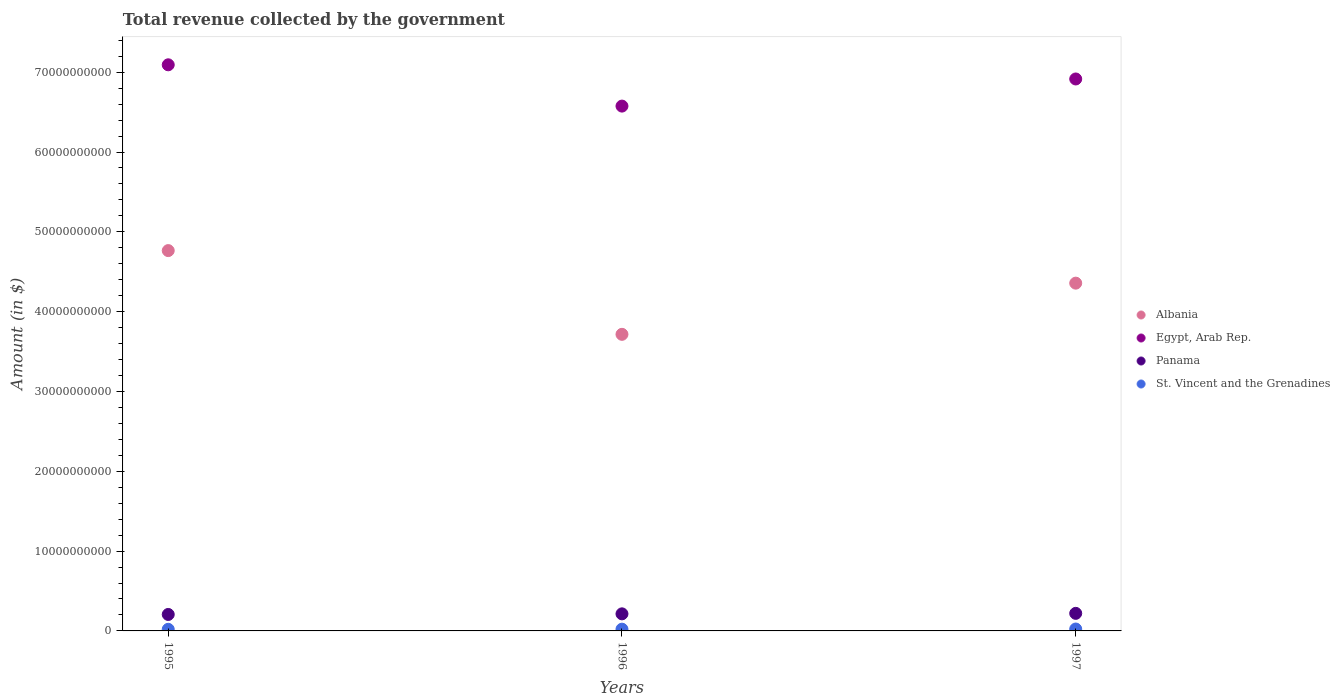How many different coloured dotlines are there?
Keep it short and to the point. 4. What is the total revenue collected by the government in Panama in 1995?
Give a very brief answer. 2.06e+09. Across all years, what is the maximum total revenue collected by the government in St. Vincent and the Grenadines?
Provide a short and direct response. 2.38e+08. Across all years, what is the minimum total revenue collected by the government in St. Vincent and the Grenadines?
Give a very brief answer. 2.02e+08. In which year was the total revenue collected by the government in St. Vincent and the Grenadines minimum?
Ensure brevity in your answer.  1995. What is the total total revenue collected by the government in Egypt, Arab Rep. in the graph?
Provide a succinct answer. 2.06e+11. What is the difference between the total revenue collected by the government in Albania in 1996 and that in 1997?
Provide a succinct answer. -6.41e+09. What is the difference between the total revenue collected by the government in Albania in 1997 and the total revenue collected by the government in Egypt, Arab Rep. in 1996?
Provide a short and direct response. -2.22e+1. What is the average total revenue collected by the government in Egypt, Arab Rep. per year?
Your response must be concise. 6.86e+1. In the year 1996, what is the difference between the total revenue collected by the government in Egypt, Arab Rep. and total revenue collected by the government in St. Vincent and the Grenadines?
Provide a succinct answer. 6.55e+1. In how many years, is the total revenue collected by the government in Egypt, Arab Rep. greater than 48000000000 $?
Your response must be concise. 3. What is the ratio of the total revenue collected by the government in Egypt, Arab Rep. in 1995 to that in 1997?
Keep it short and to the point. 1.03. Is the total revenue collected by the government in Albania in 1996 less than that in 1997?
Ensure brevity in your answer.  Yes. Is the difference between the total revenue collected by the government in Egypt, Arab Rep. in 1996 and 1997 greater than the difference between the total revenue collected by the government in St. Vincent and the Grenadines in 1996 and 1997?
Provide a short and direct response. No. What is the difference between the highest and the second highest total revenue collected by the government in Albania?
Give a very brief answer. 4.08e+09. What is the difference between the highest and the lowest total revenue collected by the government in Albania?
Offer a terse response. 1.05e+1. Is the sum of the total revenue collected by the government in St. Vincent and the Grenadines in 1995 and 1996 greater than the maximum total revenue collected by the government in Panama across all years?
Your answer should be compact. No. Is it the case that in every year, the sum of the total revenue collected by the government in Panama and total revenue collected by the government in Egypt, Arab Rep.  is greater than the sum of total revenue collected by the government in St. Vincent and the Grenadines and total revenue collected by the government in Albania?
Make the answer very short. Yes. Does the total revenue collected by the government in Panama monotonically increase over the years?
Keep it short and to the point. Yes. Is the total revenue collected by the government in Albania strictly less than the total revenue collected by the government in Egypt, Arab Rep. over the years?
Your answer should be compact. Yes. How many dotlines are there?
Ensure brevity in your answer.  4. How many years are there in the graph?
Offer a very short reply. 3. What is the difference between two consecutive major ticks on the Y-axis?
Your answer should be compact. 1.00e+1. Does the graph contain any zero values?
Make the answer very short. No. How many legend labels are there?
Your response must be concise. 4. How are the legend labels stacked?
Ensure brevity in your answer.  Vertical. What is the title of the graph?
Provide a short and direct response. Total revenue collected by the government. What is the label or title of the X-axis?
Ensure brevity in your answer.  Years. What is the label or title of the Y-axis?
Your answer should be compact. Amount (in $). What is the Amount (in $) in Albania in 1995?
Ensure brevity in your answer.  4.76e+1. What is the Amount (in $) of Egypt, Arab Rep. in 1995?
Your response must be concise. 7.09e+1. What is the Amount (in $) in Panama in 1995?
Provide a short and direct response. 2.06e+09. What is the Amount (in $) in St. Vincent and the Grenadines in 1995?
Your response must be concise. 2.02e+08. What is the Amount (in $) in Albania in 1996?
Offer a terse response. 3.72e+1. What is the Amount (in $) of Egypt, Arab Rep. in 1996?
Provide a succinct answer. 6.58e+1. What is the Amount (in $) in Panama in 1996?
Provide a succinct answer. 2.14e+09. What is the Amount (in $) in St. Vincent and the Grenadines in 1996?
Your response must be concise. 2.19e+08. What is the Amount (in $) of Albania in 1997?
Provide a short and direct response. 4.36e+1. What is the Amount (in $) of Egypt, Arab Rep. in 1997?
Your answer should be very brief. 6.92e+1. What is the Amount (in $) of Panama in 1997?
Give a very brief answer. 2.20e+09. What is the Amount (in $) of St. Vincent and the Grenadines in 1997?
Your answer should be very brief. 2.38e+08. Across all years, what is the maximum Amount (in $) of Albania?
Offer a terse response. 4.76e+1. Across all years, what is the maximum Amount (in $) in Egypt, Arab Rep.?
Provide a short and direct response. 7.09e+1. Across all years, what is the maximum Amount (in $) in Panama?
Your response must be concise. 2.20e+09. Across all years, what is the maximum Amount (in $) of St. Vincent and the Grenadines?
Give a very brief answer. 2.38e+08. Across all years, what is the minimum Amount (in $) in Albania?
Make the answer very short. 3.72e+1. Across all years, what is the minimum Amount (in $) of Egypt, Arab Rep.?
Offer a terse response. 6.58e+1. Across all years, what is the minimum Amount (in $) in Panama?
Keep it short and to the point. 2.06e+09. Across all years, what is the minimum Amount (in $) in St. Vincent and the Grenadines?
Offer a very short reply. 2.02e+08. What is the total Amount (in $) of Albania in the graph?
Ensure brevity in your answer.  1.28e+11. What is the total Amount (in $) in Egypt, Arab Rep. in the graph?
Provide a short and direct response. 2.06e+11. What is the total Amount (in $) of Panama in the graph?
Your response must be concise. 6.40e+09. What is the total Amount (in $) in St. Vincent and the Grenadines in the graph?
Your response must be concise. 6.59e+08. What is the difference between the Amount (in $) in Albania in 1995 and that in 1996?
Your answer should be very brief. 1.05e+1. What is the difference between the Amount (in $) in Egypt, Arab Rep. in 1995 and that in 1996?
Provide a short and direct response. 5.17e+09. What is the difference between the Amount (in $) in Panama in 1995 and that in 1996?
Make the answer very short. -7.56e+07. What is the difference between the Amount (in $) in St. Vincent and the Grenadines in 1995 and that in 1996?
Your answer should be compact. -1.74e+07. What is the difference between the Amount (in $) in Albania in 1995 and that in 1997?
Offer a terse response. 4.08e+09. What is the difference between the Amount (in $) of Egypt, Arab Rep. in 1995 and that in 1997?
Keep it short and to the point. 1.78e+09. What is the difference between the Amount (in $) of Panama in 1995 and that in 1997?
Offer a terse response. -1.37e+08. What is the difference between the Amount (in $) in St. Vincent and the Grenadines in 1995 and that in 1997?
Provide a succinct answer. -3.66e+07. What is the difference between the Amount (in $) in Albania in 1996 and that in 1997?
Ensure brevity in your answer.  -6.41e+09. What is the difference between the Amount (in $) of Egypt, Arab Rep. in 1996 and that in 1997?
Your answer should be compact. -3.40e+09. What is the difference between the Amount (in $) of Panama in 1996 and that in 1997?
Your response must be concise. -6.15e+07. What is the difference between the Amount (in $) in St. Vincent and the Grenadines in 1996 and that in 1997?
Your answer should be very brief. -1.92e+07. What is the difference between the Amount (in $) of Albania in 1995 and the Amount (in $) of Egypt, Arab Rep. in 1996?
Make the answer very short. -1.81e+1. What is the difference between the Amount (in $) in Albania in 1995 and the Amount (in $) in Panama in 1996?
Your response must be concise. 4.55e+1. What is the difference between the Amount (in $) in Albania in 1995 and the Amount (in $) in St. Vincent and the Grenadines in 1996?
Ensure brevity in your answer.  4.74e+1. What is the difference between the Amount (in $) of Egypt, Arab Rep. in 1995 and the Amount (in $) of Panama in 1996?
Ensure brevity in your answer.  6.88e+1. What is the difference between the Amount (in $) of Egypt, Arab Rep. in 1995 and the Amount (in $) of St. Vincent and the Grenadines in 1996?
Keep it short and to the point. 7.07e+1. What is the difference between the Amount (in $) in Panama in 1995 and the Amount (in $) in St. Vincent and the Grenadines in 1996?
Provide a succinct answer. 1.84e+09. What is the difference between the Amount (in $) of Albania in 1995 and the Amount (in $) of Egypt, Arab Rep. in 1997?
Offer a very short reply. -2.15e+1. What is the difference between the Amount (in $) of Albania in 1995 and the Amount (in $) of Panama in 1997?
Your answer should be compact. 4.54e+1. What is the difference between the Amount (in $) of Albania in 1995 and the Amount (in $) of St. Vincent and the Grenadines in 1997?
Keep it short and to the point. 4.74e+1. What is the difference between the Amount (in $) of Egypt, Arab Rep. in 1995 and the Amount (in $) of Panama in 1997?
Keep it short and to the point. 6.87e+1. What is the difference between the Amount (in $) in Egypt, Arab Rep. in 1995 and the Amount (in $) in St. Vincent and the Grenadines in 1997?
Your answer should be compact. 7.07e+1. What is the difference between the Amount (in $) of Panama in 1995 and the Amount (in $) of St. Vincent and the Grenadines in 1997?
Your answer should be very brief. 1.82e+09. What is the difference between the Amount (in $) of Albania in 1996 and the Amount (in $) of Egypt, Arab Rep. in 1997?
Provide a succinct answer. -3.20e+1. What is the difference between the Amount (in $) in Albania in 1996 and the Amount (in $) in Panama in 1997?
Ensure brevity in your answer.  3.50e+1. What is the difference between the Amount (in $) in Albania in 1996 and the Amount (in $) in St. Vincent and the Grenadines in 1997?
Offer a terse response. 3.69e+1. What is the difference between the Amount (in $) of Egypt, Arab Rep. in 1996 and the Amount (in $) of Panama in 1997?
Provide a short and direct response. 6.36e+1. What is the difference between the Amount (in $) in Egypt, Arab Rep. in 1996 and the Amount (in $) in St. Vincent and the Grenadines in 1997?
Provide a succinct answer. 6.55e+1. What is the difference between the Amount (in $) in Panama in 1996 and the Amount (in $) in St. Vincent and the Grenadines in 1997?
Keep it short and to the point. 1.90e+09. What is the average Amount (in $) in Albania per year?
Make the answer very short. 4.28e+1. What is the average Amount (in $) in Egypt, Arab Rep. per year?
Provide a short and direct response. 6.86e+1. What is the average Amount (in $) of Panama per year?
Give a very brief answer. 2.13e+09. What is the average Amount (in $) of St. Vincent and the Grenadines per year?
Your answer should be compact. 2.20e+08. In the year 1995, what is the difference between the Amount (in $) of Albania and Amount (in $) of Egypt, Arab Rep.?
Provide a short and direct response. -2.33e+1. In the year 1995, what is the difference between the Amount (in $) of Albania and Amount (in $) of Panama?
Give a very brief answer. 4.56e+1. In the year 1995, what is the difference between the Amount (in $) of Albania and Amount (in $) of St. Vincent and the Grenadines?
Offer a very short reply. 4.74e+1. In the year 1995, what is the difference between the Amount (in $) in Egypt, Arab Rep. and Amount (in $) in Panama?
Provide a short and direct response. 6.89e+1. In the year 1995, what is the difference between the Amount (in $) in Egypt, Arab Rep. and Amount (in $) in St. Vincent and the Grenadines?
Provide a short and direct response. 7.07e+1. In the year 1995, what is the difference between the Amount (in $) of Panama and Amount (in $) of St. Vincent and the Grenadines?
Ensure brevity in your answer.  1.86e+09. In the year 1996, what is the difference between the Amount (in $) of Albania and Amount (in $) of Egypt, Arab Rep.?
Give a very brief answer. -2.86e+1. In the year 1996, what is the difference between the Amount (in $) in Albania and Amount (in $) in Panama?
Offer a terse response. 3.50e+1. In the year 1996, what is the difference between the Amount (in $) of Albania and Amount (in $) of St. Vincent and the Grenadines?
Offer a very short reply. 3.69e+1. In the year 1996, what is the difference between the Amount (in $) of Egypt, Arab Rep. and Amount (in $) of Panama?
Make the answer very short. 6.36e+1. In the year 1996, what is the difference between the Amount (in $) of Egypt, Arab Rep. and Amount (in $) of St. Vincent and the Grenadines?
Your answer should be very brief. 6.55e+1. In the year 1996, what is the difference between the Amount (in $) in Panama and Amount (in $) in St. Vincent and the Grenadines?
Offer a very short reply. 1.92e+09. In the year 1997, what is the difference between the Amount (in $) in Albania and Amount (in $) in Egypt, Arab Rep.?
Provide a succinct answer. -2.56e+1. In the year 1997, what is the difference between the Amount (in $) in Albania and Amount (in $) in Panama?
Give a very brief answer. 4.14e+1. In the year 1997, what is the difference between the Amount (in $) in Albania and Amount (in $) in St. Vincent and the Grenadines?
Provide a succinct answer. 4.33e+1. In the year 1997, what is the difference between the Amount (in $) in Egypt, Arab Rep. and Amount (in $) in Panama?
Keep it short and to the point. 6.69e+1. In the year 1997, what is the difference between the Amount (in $) in Egypt, Arab Rep. and Amount (in $) in St. Vincent and the Grenadines?
Ensure brevity in your answer.  6.89e+1. In the year 1997, what is the difference between the Amount (in $) in Panama and Amount (in $) in St. Vincent and the Grenadines?
Offer a very short reply. 1.96e+09. What is the ratio of the Amount (in $) of Albania in 1995 to that in 1996?
Keep it short and to the point. 1.28. What is the ratio of the Amount (in $) in Egypt, Arab Rep. in 1995 to that in 1996?
Give a very brief answer. 1.08. What is the ratio of the Amount (in $) of Panama in 1995 to that in 1996?
Keep it short and to the point. 0.96. What is the ratio of the Amount (in $) in St. Vincent and the Grenadines in 1995 to that in 1996?
Keep it short and to the point. 0.92. What is the ratio of the Amount (in $) of Albania in 1995 to that in 1997?
Give a very brief answer. 1.09. What is the ratio of the Amount (in $) in Egypt, Arab Rep. in 1995 to that in 1997?
Provide a succinct answer. 1.03. What is the ratio of the Amount (in $) of Panama in 1995 to that in 1997?
Make the answer very short. 0.94. What is the ratio of the Amount (in $) of St. Vincent and the Grenadines in 1995 to that in 1997?
Keep it short and to the point. 0.85. What is the ratio of the Amount (in $) in Albania in 1996 to that in 1997?
Offer a very short reply. 0.85. What is the ratio of the Amount (in $) of Egypt, Arab Rep. in 1996 to that in 1997?
Offer a terse response. 0.95. What is the ratio of the Amount (in $) in Panama in 1996 to that in 1997?
Your answer should be very brief. 0.97. What is the ratio of the Amount (in $) of St. Vincent and the Grenadines in 1996 to that in 1997?
Your answer should be compact. 0.92. What is the difference between the highest and the second highest Amount (in $) in Albania?
Ensure brevity in your answer.  4.08e+09. What is the difference between the highest and the second highest Amount (in $) in Egypt, Arab Rep.?
Provide a short and direct response. 1.78e+09. What is the difference between the highest and the second highest Amount (in $) of Panama?
Ensure brevity in your answer.  6.15e+07. What is the difference between the highest and the second highest Amount (in $) in St. Vincent and the Grenadines?
Your answer should be compact. 1.92e+07. What is the difference between the highest and the lowest Amount (in $) in Albania?
Your response must be concise. 1.05e+1. What is the difference between the highest and the lowest Amount (in $) of Egypt, Arab Rep.?
Provide a succinct answer. 5.17e+09. What is the difference between the highest and the lowest Amount (in $) of Panama?
Keep it short and to the point. 1.37e+08. What is the difference between the highest and the lowest Amount (in $) of St. Vincent and the Grenadines?
Provide a succinct answer. 3.66e+07. 